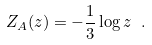Convert formula to latex. <formula><loc_0><loc_0><loc_500><loc_500>Z _ { A } ( z ) = - \frac { 1 } { 3 } \log z \ .</formula> 